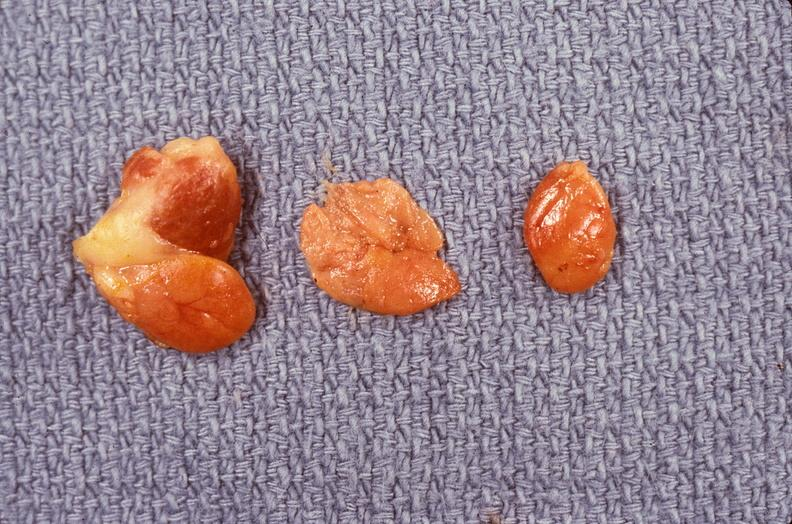s anomalous origin present?
Answer the question using a single word or phrase. No 